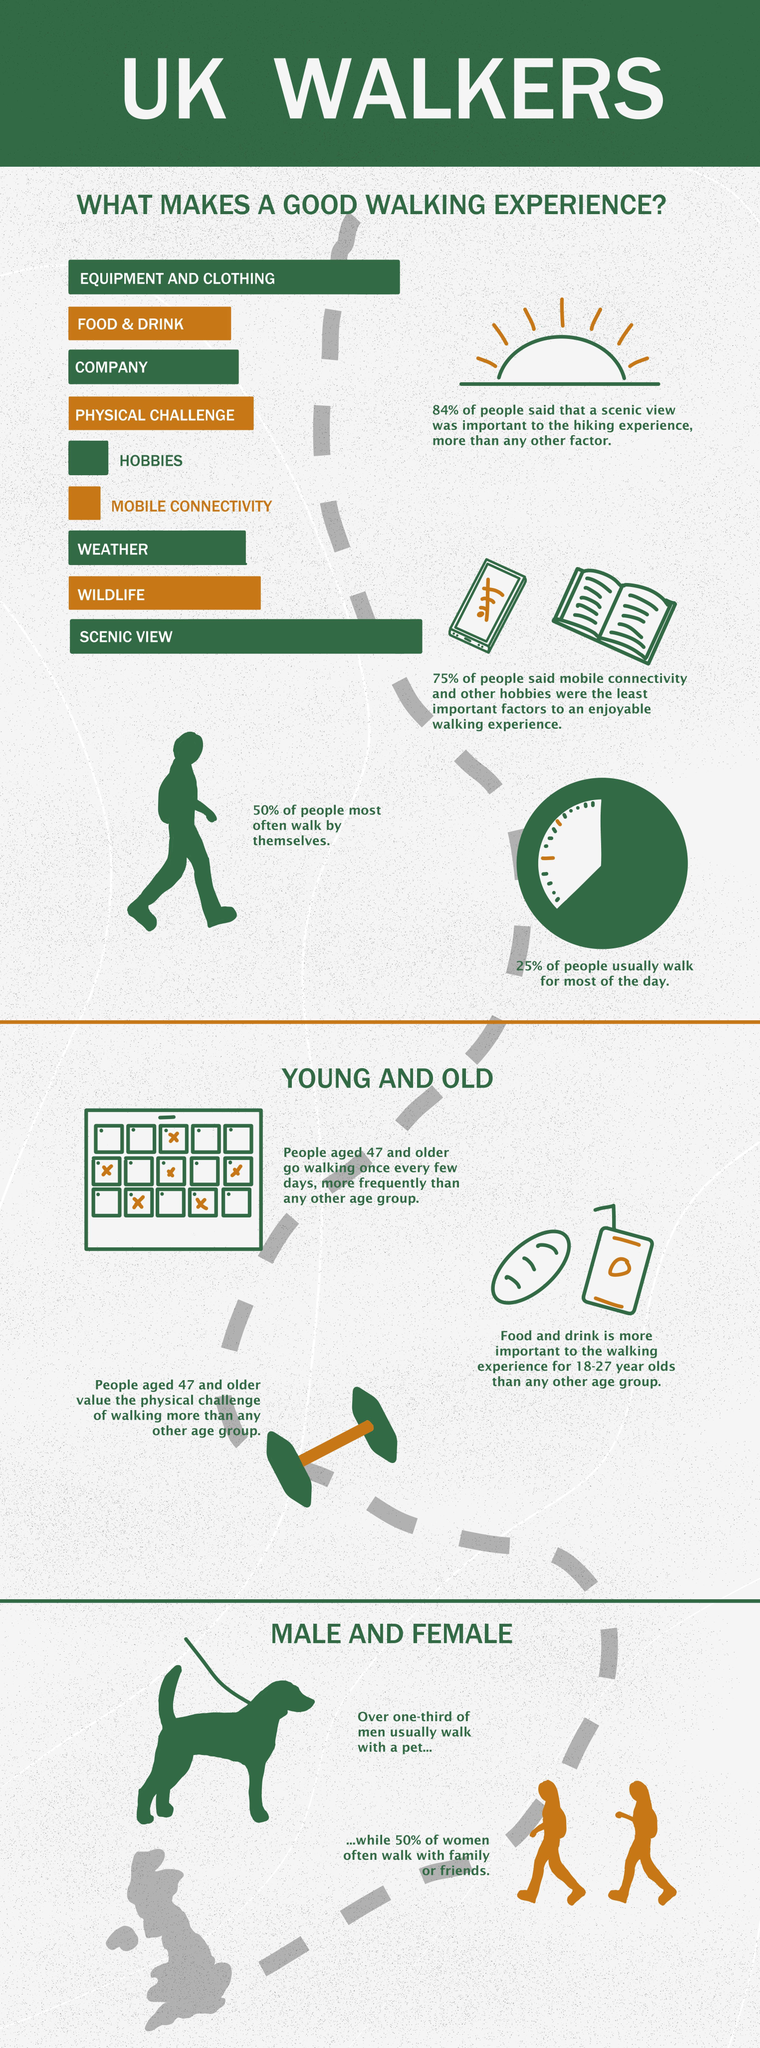Draw attention to some important aspects in this diagram. The infographic lists a total of 9 factors that contribute to a good walking experience. Equipment and clothing are the second most crucial factors that contribute to a positive and enjoyable walking experience. The scenic view is the most significant element that contributes to a positive walking experience. According to a recent survey, it was found that approximately 33.33% of men usually walk with a pet. 